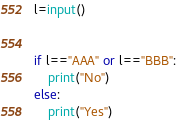Convert code to text. <code><loc_0><loc_0><loc_500><loc_500><_Python_>l=input()


if l=="AAA" or l=="BBB":
    print("No")
else:
    print("Yes")</code> 